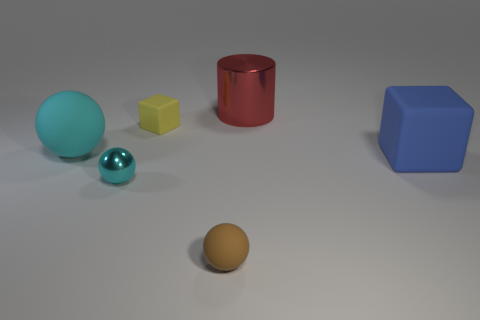Add 3 small blue rubber things. How many objects exist? 9 Subtract all large spheres. How many spheres are left? 2 Subtract all yellow cubes. Subtract all big shiny cylinders. How many objects are left? 4 Add 2 cyan objects. How many cyan objects are left? 4 Add 2 tiny brown objects. How many tiny brown objects exist? 3 Subtract all yellow blocks. How many blocks are left? 1 Subtract 0 red spheres. How many objects are left? 6 Subtract all cubes. How many objects are left? 4 Subtract 1 balls. How many balls are left? 2 Subtract all gray balls. Subtract all cyan cylinders. How many balls are left? 3 